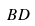Convert formula to latex. <formula><loc_0><loc_0><loc_500><loc_500>B D</formula> 